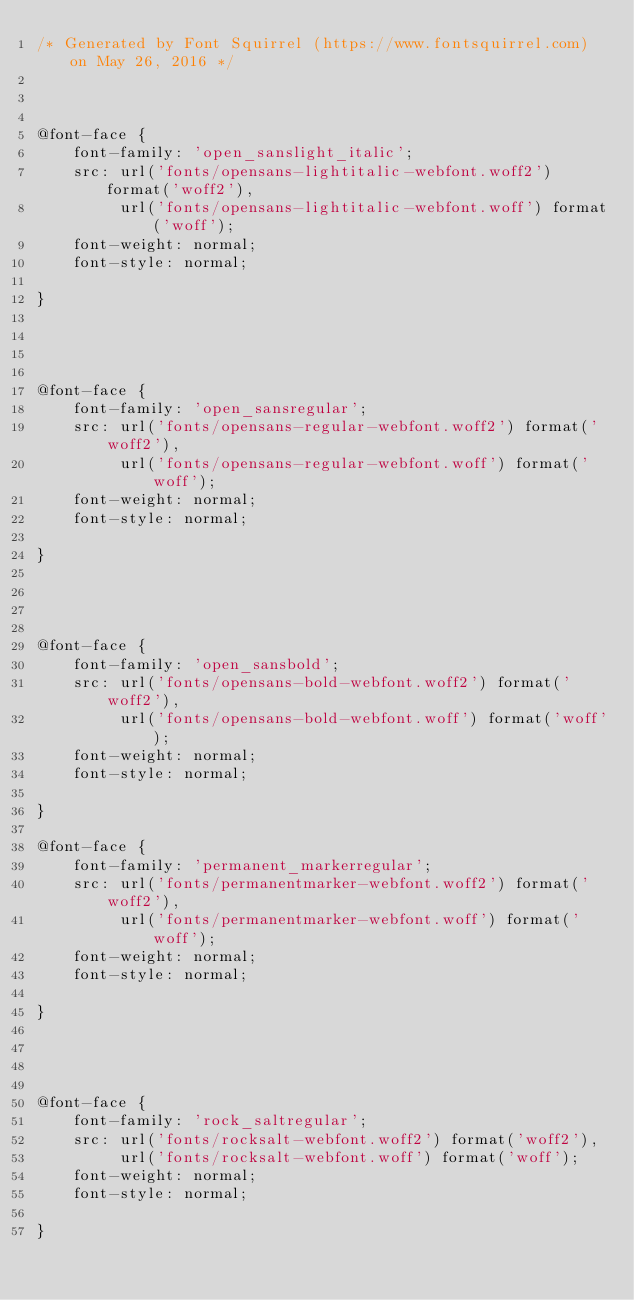Convert code to text. <code><loc_0><loc_0><loc_500><loc_500><_CSS_>/* Generated by Font Squirrel (https://www.fontsquirrel.com) on May 26, 2016 */



@font-face {
    font-family: 'open_sanslight_italic';
    src: url('fonts/opensans-lightitalic-webfont.woff2') format('woff2'),
         url('fonts/opensans-lightitalic-webfont.woff') format('woff');
    font-weight: normal;
    font-style: normal;

}




@font-face {
    font-family: 'open_sansregular';
    src: url('fonts/opensans-regular-webfont.woff2') format('woff2'),
         url('fonts/opensans-regular-webfont.woff') format('woff');
    font-weight: normal;
    font-style: normal;

}




@font-face {
    font-family: 'open_sansbold';
    src: url('fonts/opensans-bold-webfont.woff2') format('woff2'),
         url('fonts/opensans-bold-webfont.woff') format('woff');
    font-weight: normal;
    font-style: normal;

}

@font-face {
    font-family: 'permanent_markerregular';
    src: url('fonts/permanentmarker-webfont.woff2') format('woff2'),
         url('fonts/permanentmarker-webfont.woff') format('woff');
    font-weight: normal;
    font-style: normal;

}




@font-face {
    font-family: 'rock_saltregular';
    src: url('fonts/rocksalt-webfont.woff2') format('woff2'),
         url('fonts/rocksalt-webfont.woff') format('woff');
    font-weight: normal;
    font-style: normal;

}
</code> 